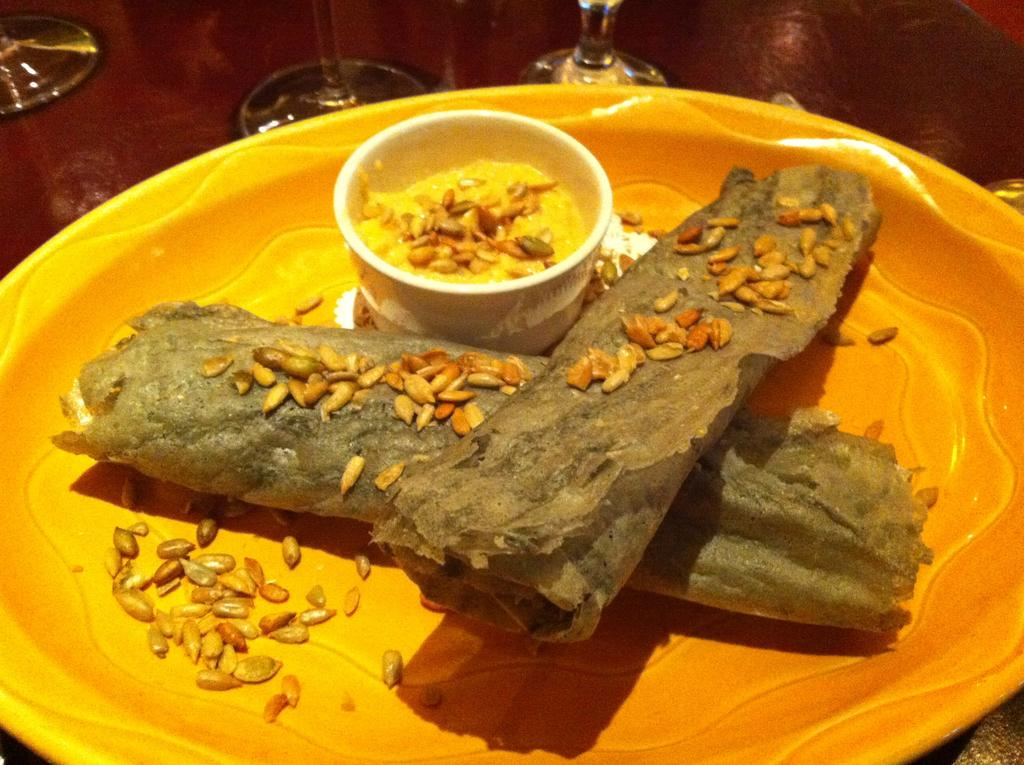What is the main food item visible in the image? There is a food item in the image, but the specific type cannot be determined from the provided facts. What is the food item placed in? The food item is placed in a bowl. How is the bowl positioned in the image? The bowl is placed on a plate. What other items can be seen in front of the plate? There are glasses in front of the plate. What type of toothpaste is being used to prepare the food item in the image? There is no toothpaste present in the image, and it is not used for preparing food. 